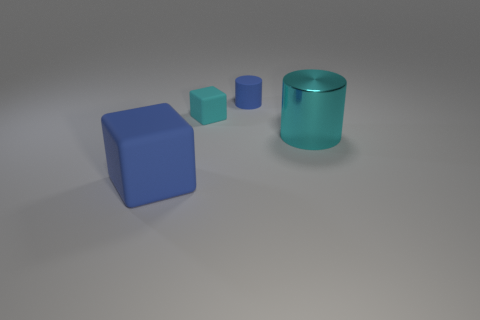The large object that is to the right of the small blue object is what color?
Keep it short and to the point. Cyan. What number of tiny matte objects are the same color as the large cube?
Provide a short and direct response. 1. What number of things are both behind the large matte cube and to the left of the big cylinder?
Provide a succinct answer. 2. There is a thing that is the same size as the blue matte cylinder; what shape is it?
Ensure brevity in your answer.  Cube. The metallic cylinder is what size?
Keep it short and to the point. Large. The cube behind the object on the right side of the matte cylinder behind the large blue object is made of what material?
Provide a succinct answer. Rubber. There is a big object that is made of the same material as the tiny cylinder; what is its color?
Your answer should be very brief. Blue. There is a big cyan thing that is behind the large thing that is left of the matte cylinder; what number of blue cubes are behind it?
Offer a very short reply. 0. What is the material of the small cylinder that is the same color as the big matte thing?
Give a very brief answer. Rubber. Is there any other thing that has the same shape as the large blue thing?
Your response must be concise. Yes. 